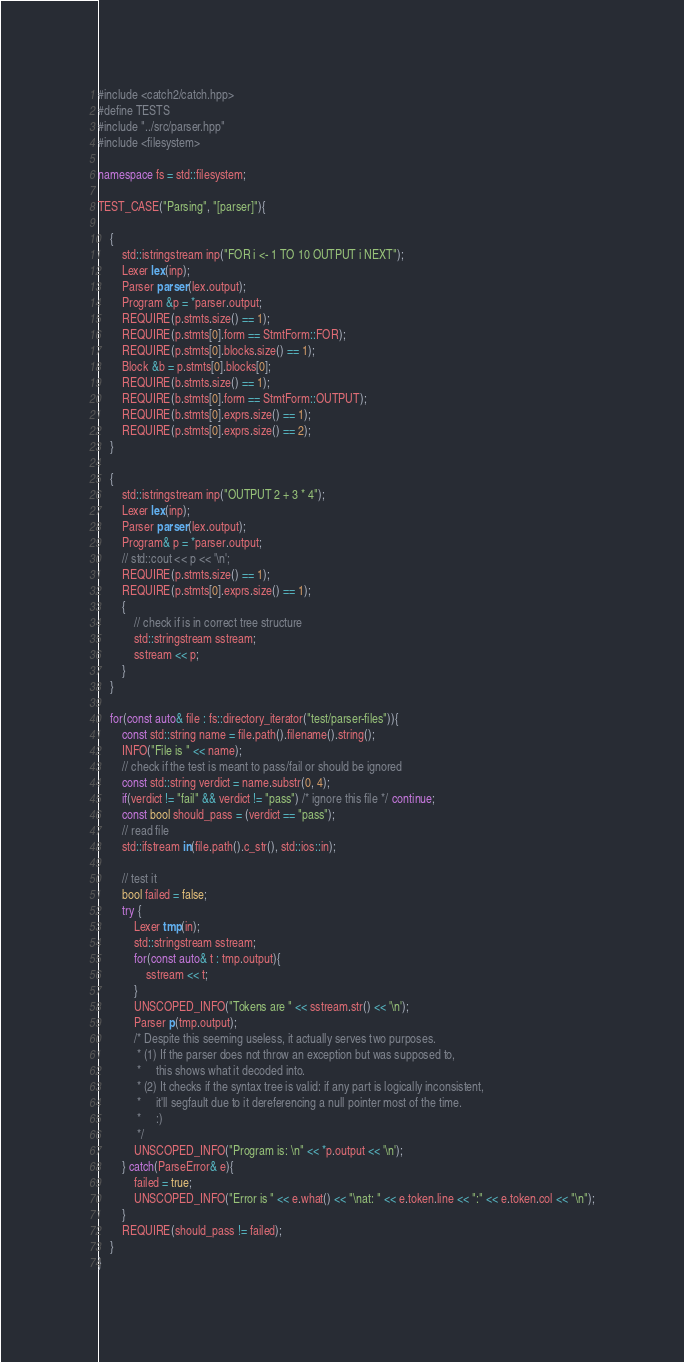Convert code to text. <code><loc_0><loc_0><loc_500><loc_500><_C++_>#include <catch2/catch.hpp>
#define TESTS
#include "../src/parser.hpp"
#include <filesystem>

namespace fs = std::filesystem;

TEST_CASE("Parsing", "[parser]"){

	{
		std::istringstream inp("FOR i <- 1 TO 10 OUTPUT i NEXT");
		Lexer lex(inp);
		Parser parser(lex.output);
		Program &p = *parser.output;
		REQUIRE(p.stmts.size() == 1);
		REQUIRE(p.stmts[0].form == StmtForm::FOR);
		REQUIRE(p.stmts[0].blocks.size() == 1);
		Block &b = p.stmts[0].blocks[0];
		REQUIRE(b.stmts.size() == 1);
		REQUIRE(b.stmts[0].form == StmtForm::OUTPUT);
		REQUIRE(b.stmts[0].exprs.size() == 1);
		REQUIRE(p.stmts[0].exprs.size() == 2);
	}

	{ 
		std::istringstream inp("OUTPUT 2 + 3 * 4");
		Lexer lex(inp);
		Parser parser(lex.output);
		Program& p = *parser.output;
		// std::cout << p << '\n';
		REQUIRE(p.stmts.size() == 1);
		REQUIRE(p.stmts[0].exprs.size() == 1);
		{
			// check if is in correct tree structure
			std::stringstream sstream;
			sstream << p;
		}
	}

	for(const auto& file : fs::directory_iterator("test/parser-files")){
		const std::string name = file.path().filename().string();
		INFO("File is " << name);
		// check if the test is meant to pass/fail or should be ignored
		const std::string verdict = name.substr(0, 4);
		if(verdict != "fail" && verdict != "pass") /* ignore this file */ continue;
		const bool should_pass = (verdict == "pass");
		// read file
		std::ifstream in(file.path().c_str(), std::ios::in);

		// test it
		bool failed = false;
		try {
			Lexer tmp(in);
			std::stringstream sstream;
			for(const auto& t : tmp.output){
				sstream << t;
			}
			UNSCOPED_INFO("Tokens are " << sstream.str() << '\n');
			Parser p(tmp.output);
			/* Despite this seeming useless, it actually serves two purposes.
			 * (1) If the parser does not throw an exception but was supposed to, 
			 *     this shows what it decoded into.
			 * (2) It checks if the syntax tree is valid: if any part is logically inconsistent,
			 *     it'll segfault due to it dereferencing a null pointer most of the time.
			 *     :)
			 */
			UNSCOPED_INFO("Program is: \n" << *p.output << '\n');
		} catch(ParseError& e){
			failed = true;
			UNSCOPED_INFO("Error is " << e.what() << "\nat: " << e.token.line << ":" << e.token.col << "\n");
		}
		REQUIRE(should_pass != failed);
	}
}

</code> 